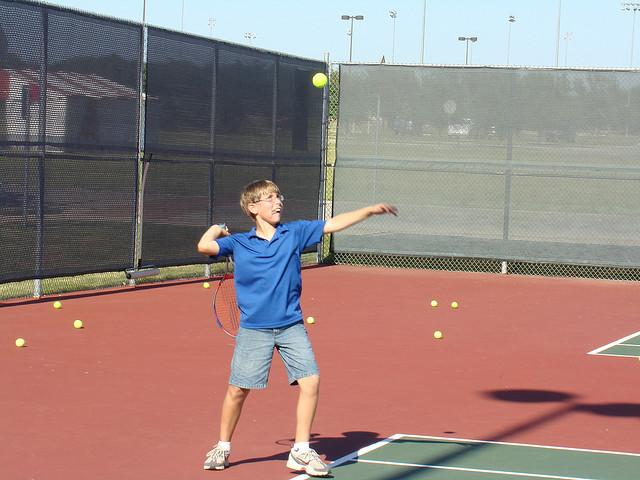What type of shot is the boy about to hit? serve 